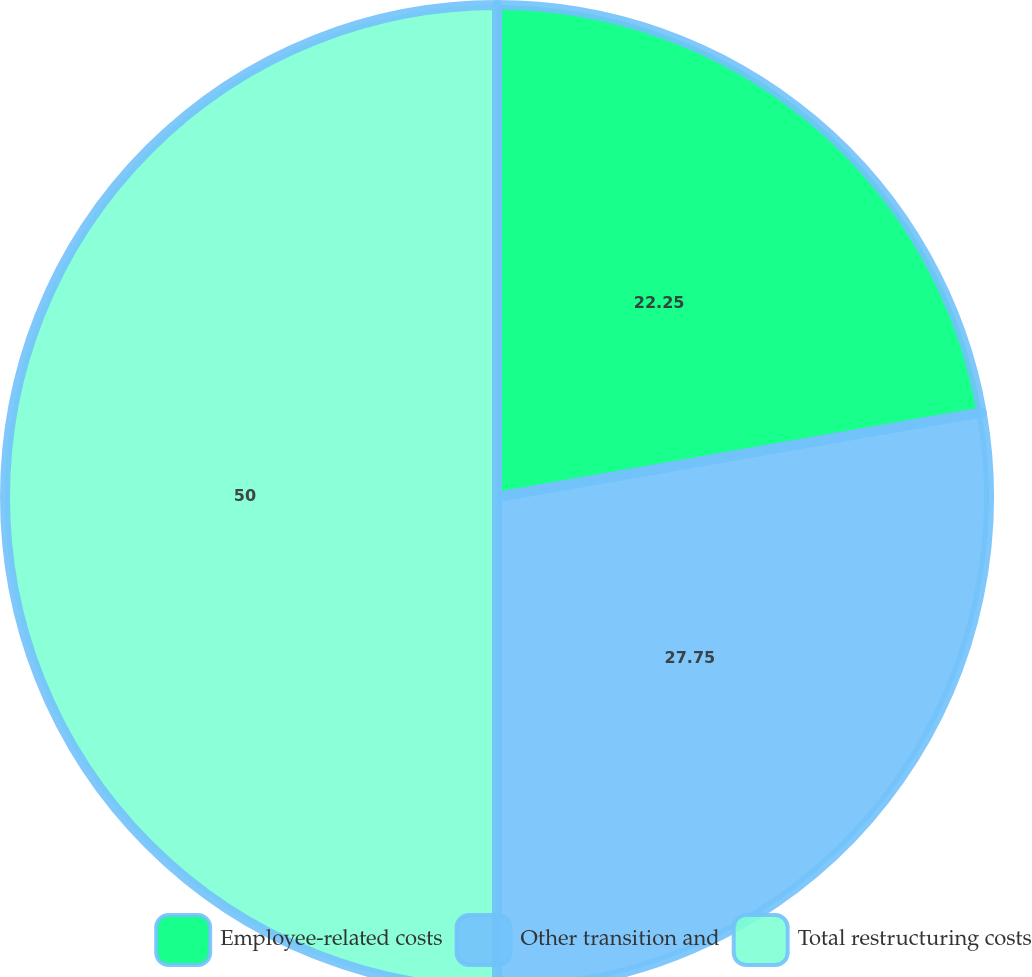<chart> <loc_0><loc_0><loc_500><loc_500><pie_chart><fcel>Employee-related costs<fcel>Other transition and<fcel>Total restructuring costs<nl><fcel>22.25%<fcel>27.75%<fcel>50.0%<nl></chart> 